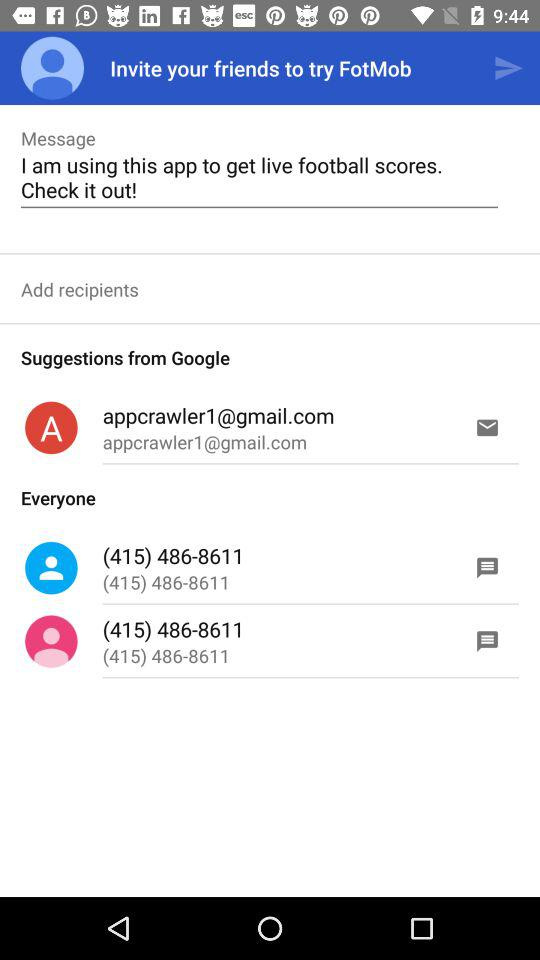What's the country code? The country code is (415). 